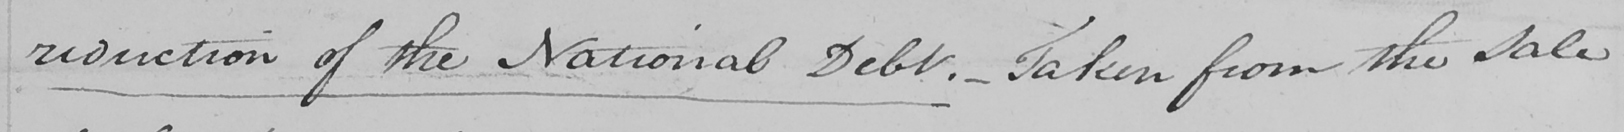What text is written in this handwritten line? reduction of the National Debt .  _  Taken from the Sale 